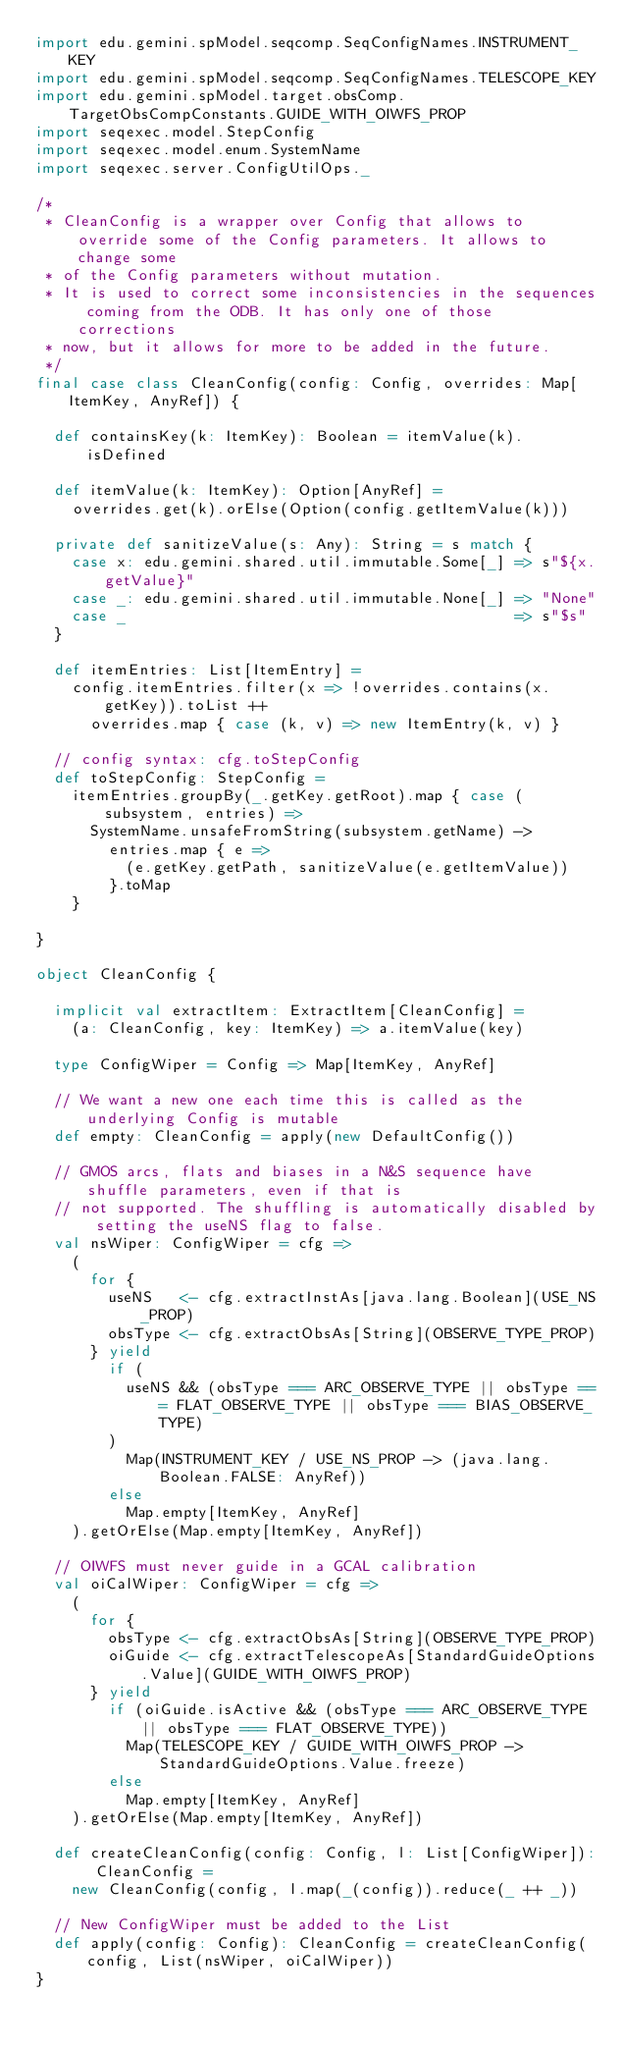Convert code to text. <code><loc_0><loc_0><loc_500><loc_500><_Scala_>import edu.gemini.spModel.seqcomp.SeqConfigNames.INSTRUMENT_KEY
import edu.gemini.spModel.seqcomp.SeqConfigNames.TELESCOPE_KEY
import edu.gemini.spModel.target.obsComp.TargetObsCompConstants.GUIDE_WITH_OIWFS_PROP
import seqexec.model.StepConfig
import seqexec.model.enum.SystemName
import seqexec.server.ConfigUtilOps._

/*
 * CleanConfig is a wrapper over Config that allows to override some of the Config parameters. It allows to change some
 * of the Config parameters without mutation.
 * It is used to correct some inconsistencies in the sequences coming from the ODB. It has only one of those corrections
 * now, but it allows for more to be added in the future.
 */
final case class CleanConfig(config: Config, overrides: Map[ItemKey, AnyRef]) {

  def containsKey(k: ItemKey): Boolean = itemValue(k).isDefined

  def itemValue(k: ItemKey): Option[AnyRef] =
    overrides.get(k).orElse(Option(config.getItemValue(k)))

  private def sanitizeValue(s: Any): String = s match {
    case x: edu.gemini.shared.util.immutable.Some[_] => s"${x.getValue}"
    case _: edu.gemini.shared.util.immutable.None[_] => "None"
    case _                                           => s"$s"
  }

  def itemEntries: List[ItemEntry] =
    config.itemEntries.filter(x => !overrides.contains(x.getKey)).toList ++
      overrides.map { case (k, v) => new ItemEntry(k, v) }

  // config syntax: cfg.toStepConfig
  def toStepConfig: StepConfig =
    itemEntries.groupBy(_.getKey.getRoot).map { case (subsystem, entries) =>
      SystemName.unsafeFromString(subsystem.getName) ->
        entries.map { e =>
          (e.getKey.getPath, sanitizeValue(e.getItemValue))
        }.toMap
    }

}

object CleanConfig {

  implicit val extractItem: ExtractItem[CleanConfig] =
    (a: CleanConfig, key: ItemKey) => a.itemValue(key)

  type ConfigWiper = Config => Map[ItemKey, AnyRef]

  // We want a new one each time this is called as the underlying Config is mutable
  def empty: CleanConfig = apply(new DefaultConfig())

  // GMOS arcs, flats and biases in a N&S sequence have shuffle parameters, even if that is
  // not supported. The shuffling is automatically disabled by setting the useNS flag to false.
  val nsWiper: ConfigWiper = cfg =>
    (
      for {
        useNS   <- cfg.extractInstAs[java.lang.Boolean](USE_NS_PROP)
        obsType <- cfg.extractObsAs[String](OBSERVE_TYPE_PROP)
      } yield
        if (
          useNS && (obsType === ARC_OBSERVE_TYPE || obsType === FLAT_OBSERVE_TYPE || obsType === BIAS_OBSERVE_TYPE)
        )
          Map(INSTRUMENT_KEY / USE_NS_PROP -> (java.lang.Boolean.FALSE: AnyRef))
        else
          Map.empty[ItemKey, AnyRef]
    ).getOrElse(Map.empty[ItemKey, AnyRef])

  // OIWFS must never guide in a GCAL calibration
  val oiCalWiper: ConfigWiper = cfg =>
    (
      for {
        obsType <- cfg.extractObsAs[String](OBSERVE_TYPE_PROP)
        oiGuide <- cfg.extractTelescopeAs[StandardGuideOptions.Value](GUIDE_WITH_OIWFS_PROP)
      } yield
        if (oiGuide.isActive && (obsType === ARC_OBSERVE_TYPE || obsType === FLAT_OBSERVE_TYPE))
          Map(TELESCOPE_KEY / GUIDE_WITH_OIWFS_PROP -> StandardGuideOptions.Value.freeze)
        else
          Map.empty[ItemKey, AnyRef]
    ).getOrElse(Map.empty[ItemKey, AnyRef])

  def createCleanConfig(config: Config, l: List[ConfigWiper]): CleanConfig =
    new CleanConfig(config, l.map(_(config)).reduce(_ ++ _))

  // New ConfigWiper must be added to the List
  def apply(config: Config): CleanConfig = createCleanConfig(config, List(nsWiper, oiCalWiper))
}
</code> 